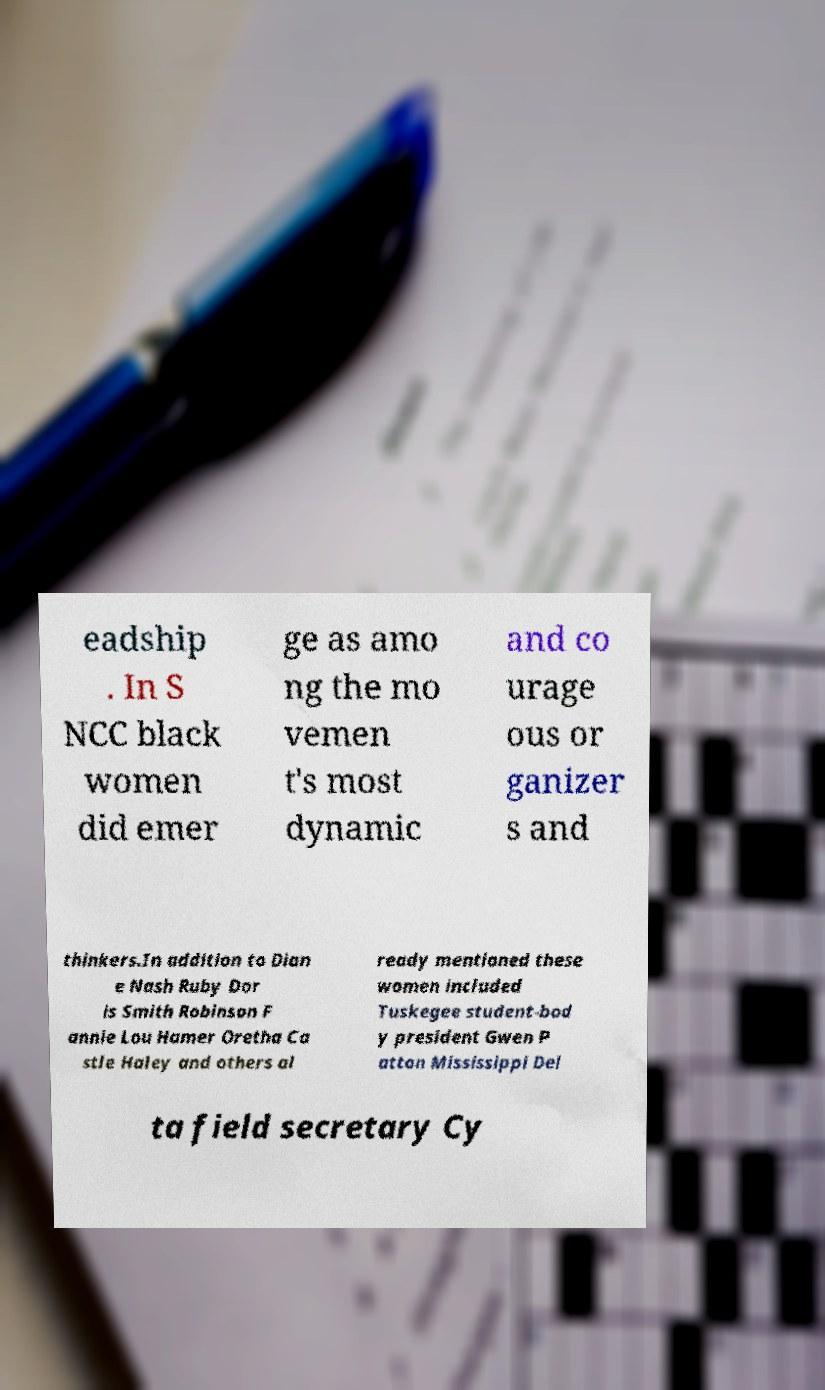Please identify and transcribe the text found in this image. eadship . In S NCC black women did emer ge as amo ng the mo vemen t's most dynamic and co urage ous or ganizer s and thinkers.In addition to Dian e Nash Ruby Dor is Smith Robinson F annie Lou Hamer Oretha Ca stle Haley and others al ready mentioned these women included Tuskegee student-bod y president Gwen P atton Mississippi Del ta field secretary Cy 